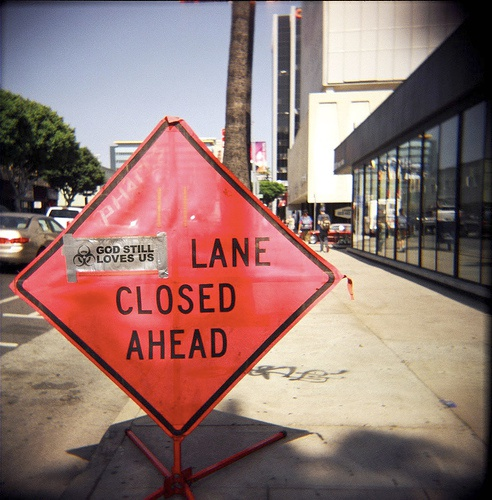Describe the objects in this image and their specific colors. I can see car in black, gray, white, and tan tones, car in black, maroon, lightgray, and lightpink tones, people in black, gray, and tan tones, people in black, brown, darkgray, lightgray, and maroon tones, and people in black, gray, and darkgray tones in this image. 